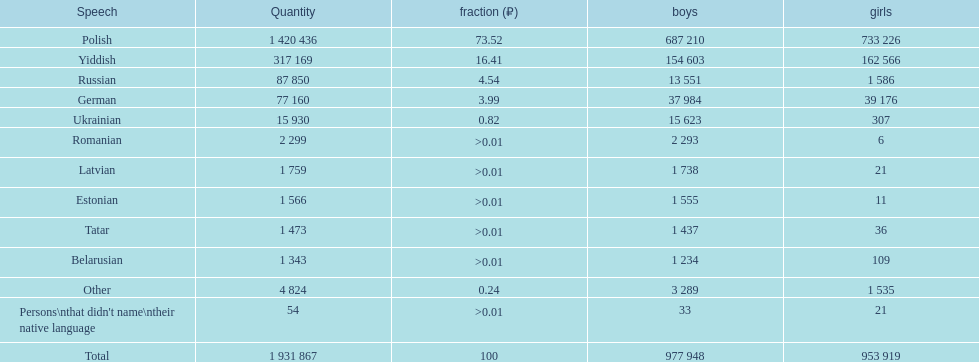Is german above or below russia in the number of people who speak that language? Below. 